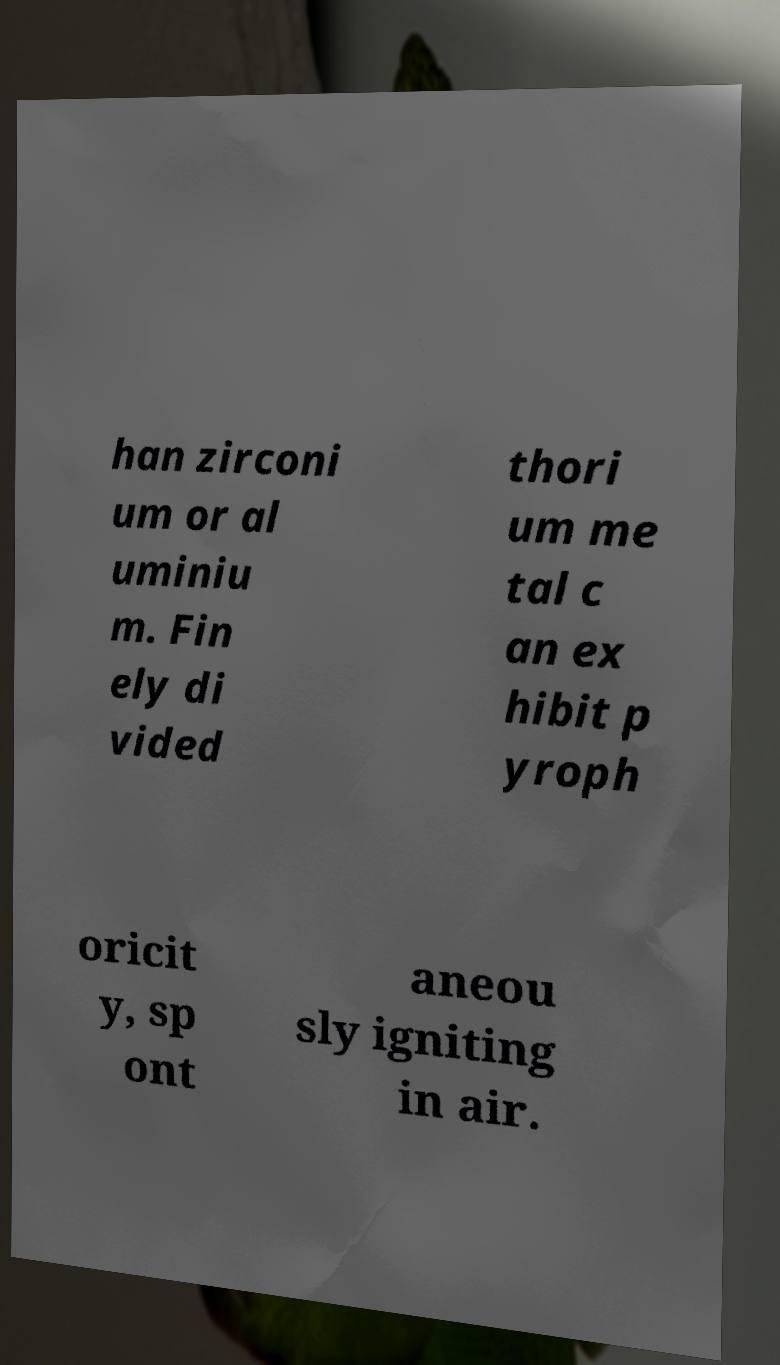Can you read and provide the text displayed in the image?This photo seems to have some interesting text. Can you extract and type it out for me? han zirconi um or al uminiu m. Fin ely di vided thori um me tal c an ex hibit p yroph oricit y, sp ont aneou sly igniting in air. 